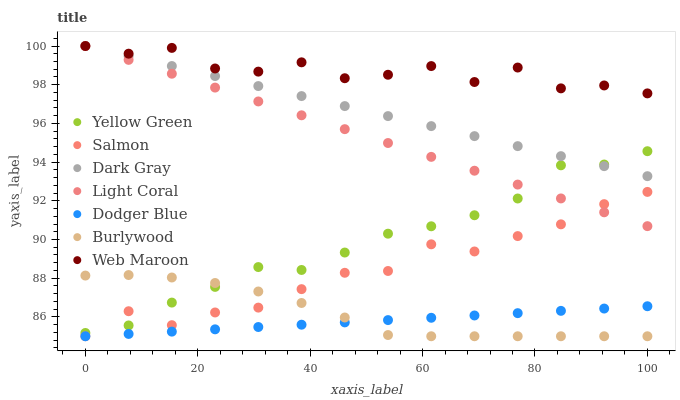Does Dodger Blue have the minimum area under the curve?
Answer yes or no. Yes. Does Web Maroon have the maximum area under the curve?
Answer yes or no. Yes. Does Yellow Green have the minimum area under the curve?
Answer yes or no. No. Does Yellow Green have the maximum area under the curve?
Answer yes or no. No. Is Light Coral the smoothest?
Answer yes or no. Yes. Is Web Maroon the roughest?
Answer yes or no. Yes. Is Yellow Green the smoothest?
Answer yes or no. No. Is Yellow Green the roughest?
Answer yes or no. No. Does Burlywood have the lowest value?
Answer yes or no. Yes. Does Yellow Green have the lowest value?
Answer yes or no. No. Does Dark Gray have the highest value?
Answer yes or no. Yes. Does Yellow Green have the highest value?
Answer yes or no. No. Is Burlywood less than Light Coral?
Answer yes or no. Yes. Is Light Coral greater than Burlywood?
Answer yes or no. Yes. Does Dodger Blue intersect Salmon?
Answer yes or no. Yes. Is Dodger Blue less than Salmon?
Answer yes or no. No. Is Dodger Blue greater than Salmon?
Answer yes or no. No. Does Burlywood intersect Light Coral?
Answer yes or no. No. 